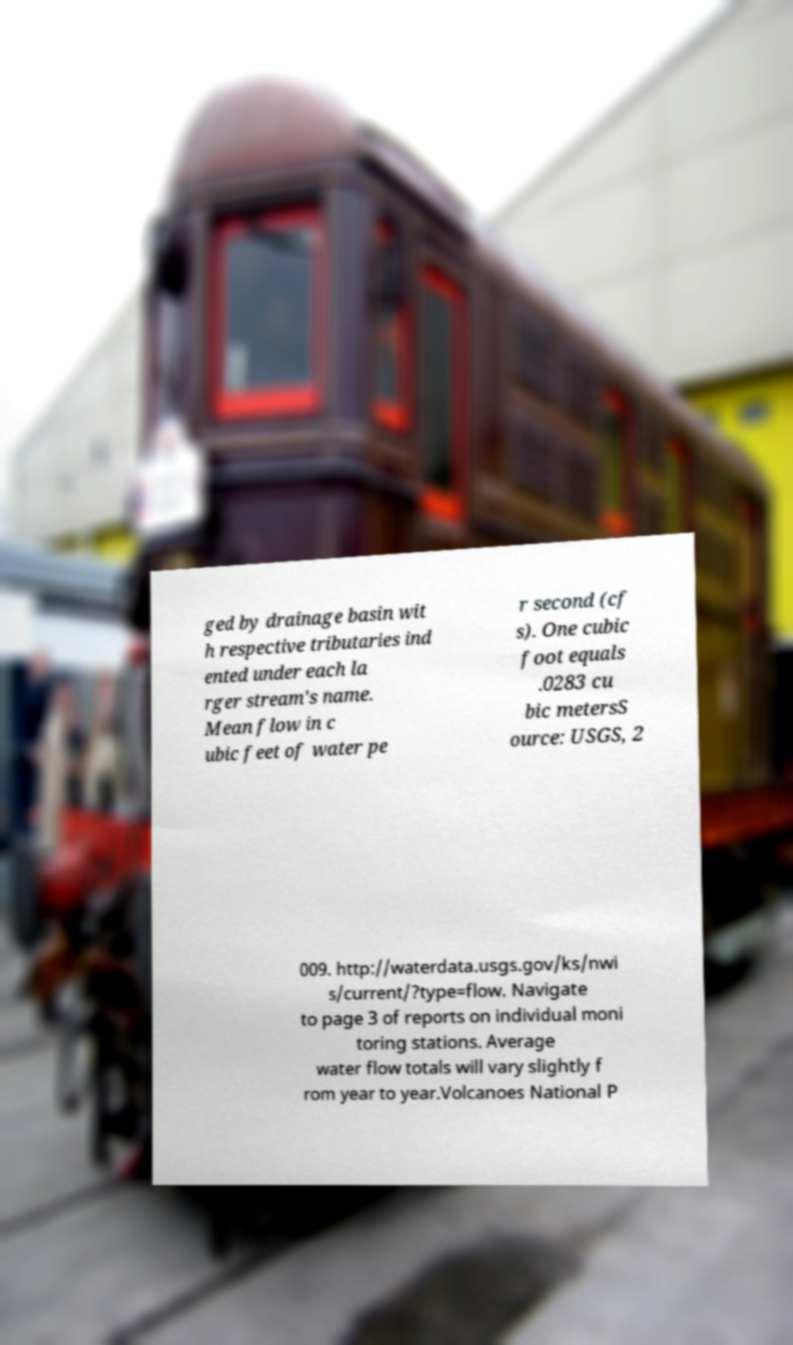Could you assist in decoding the text presented in this image and type it out clearly? ged by drainage basin wit h respective tributaries ind ented under each la rger stream's name. Mean flow in c ubic feet of water pe r second (cf s). One cubic foot equals .0283 cu bic metersS ource: USGS, 2 009. http://waterdata.usgs.gov/ks/nwi s/current/?type=flow. Navigate to page 3 of reports on individual moni toring stations. Average water flow totals will vary slightly f rom year to year.Volcanoes National P 